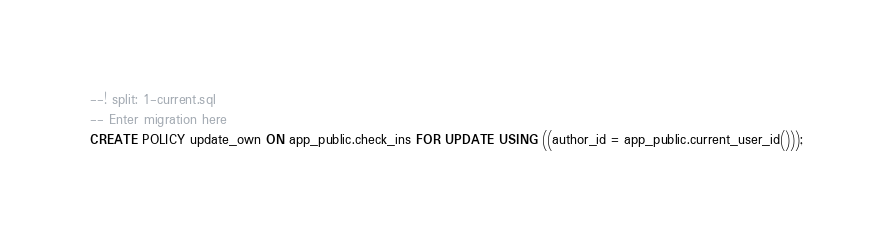Convert code to text. <code><loc_0><loc_0><loc_500><loc_500><_SQL_>
--! split: 1-current.sql
-- Enter migration here
CREATE POLICY update_own ON app_public.check_ins FOR UPDATE USING ((author_id = app_public.current_user_id()));
</code> 